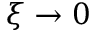Convert formula to latex. <formula><loc_0><loc_0><loc_500><loc_500>\xi \to 0</formula> 